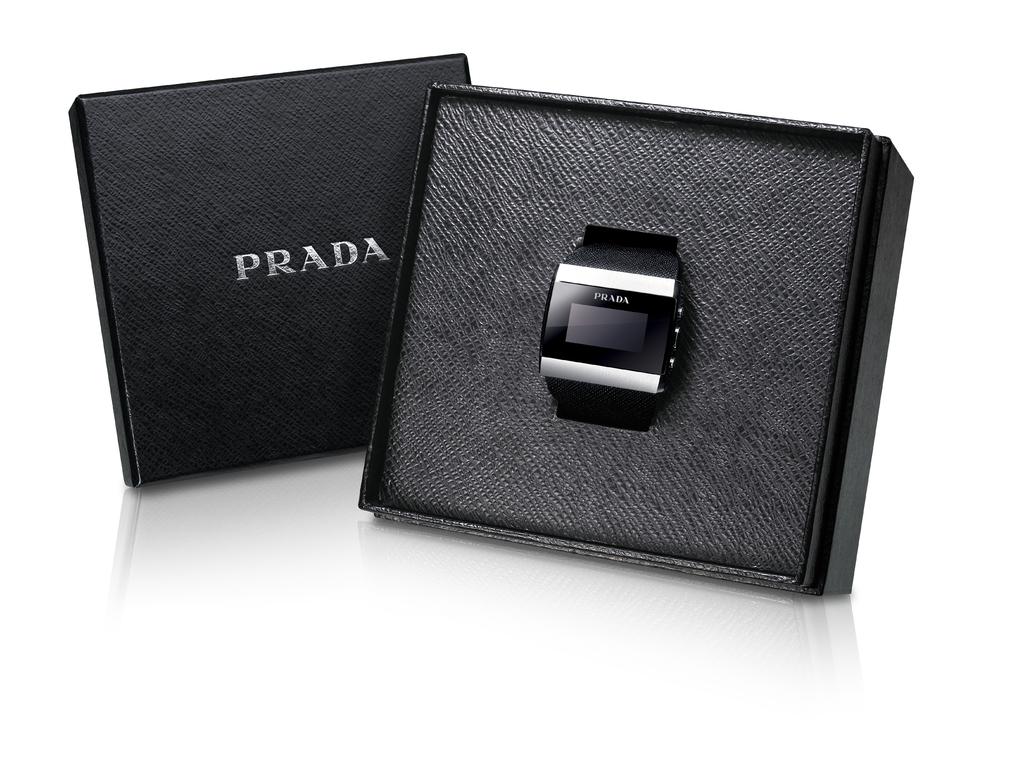What luxury brand is the watch?
Offer a terse response. Prada. 